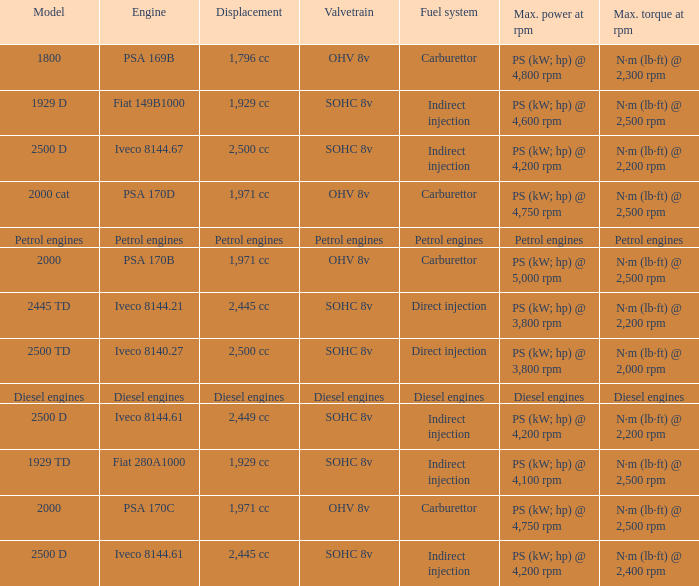What Valvetrain has a fuel system made up of petrol engines? Petrol engines. 